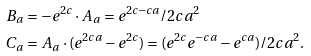Convert formula to latex. <formula><loc_0><loc_0><loc_500><loc_500>B _ { a } & = - e ^ { 2 c } \cdot A _ { a } = e ^ { 2 c - c a } / 2 c a ^ { 2 } \\ C _ { a } & = A _ { a } \cdot ( e ^ { 2 c a } - e ^ { 2 c } ) = ( e ^ { 2 c } e ^ { - c a } - e ^ { c a } ) / 2 c a ^ { 2 } .</formula> 